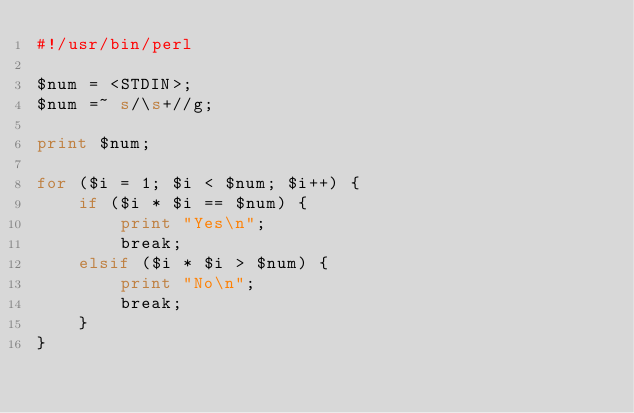<code> <loc_0><loc_0><loc_500><loc_500><_Perl_>#!/usr/bin/perl

$num = <STDIN>;
$num =~ s/\s+//g;

print $num;

for ($i = 1; $i < $num; $i++) {
    if ($i * $i == $num) {
        print "Yes\n";
        break;
    elsif ($i * $i > $num) {
        print "No\n";
        break;
    }
}</code> 